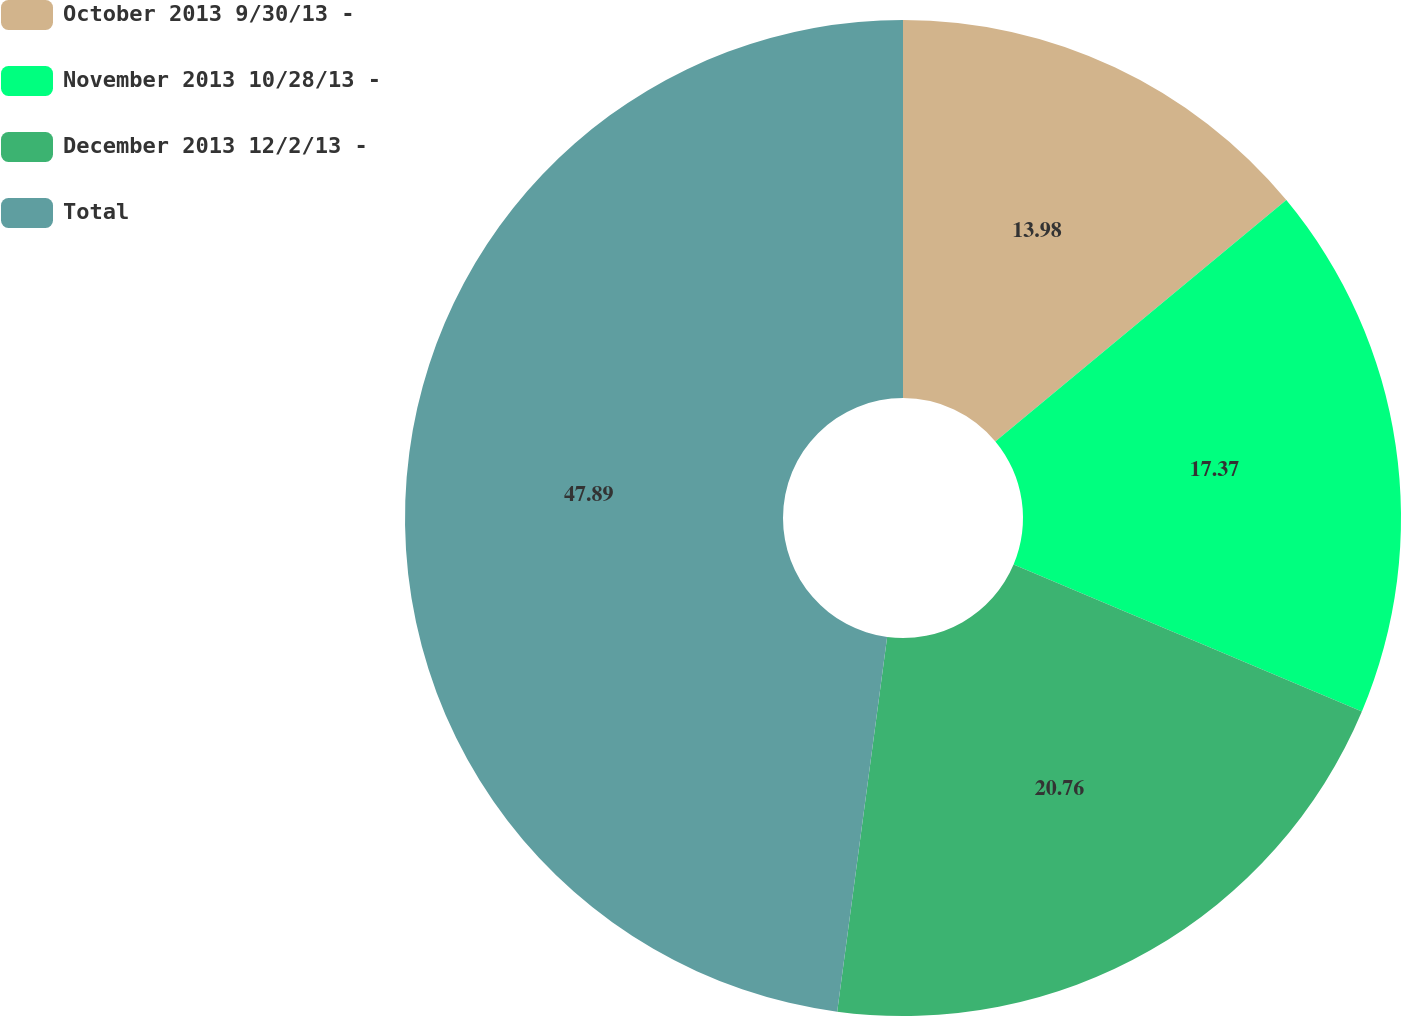Convert chart to OTSL. <chart><loc_0><loc_0><loc_500><loc_500><pie_chart><fcel>October 2013 9/30/13 -<fcel>November 2013 10/28/13 -<fcel>December 2013 12/2/13 -<fcel>Total<nl><fcel>13.98%<fcel>17.37%<fcel>20.76%<fcel>47.89%<nl></chart> 